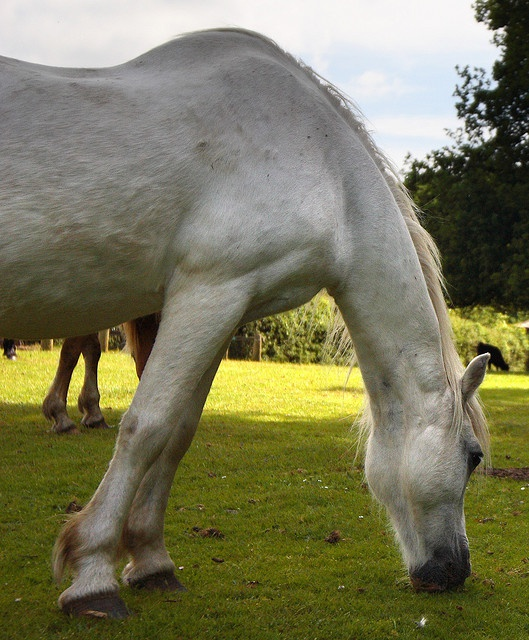Describe the objects in this image and their specific colors. I can see horse in lightgray, gray, darkgray, darkgreen, and black tones and horse in lightgray, black, maroon, olive, and gray tones in this image. 